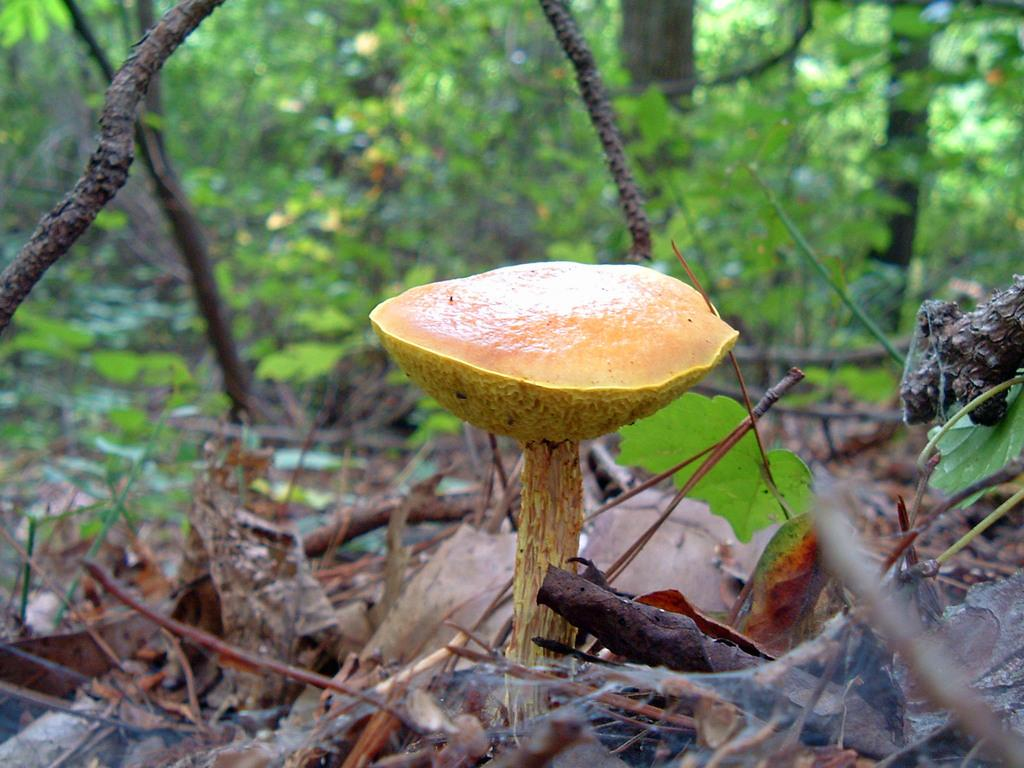What is the main subject of the image? There is a mushroom in the image. What can be seen in the foreground of the image? There are dry leaves in the front of the image. What type of vegetation is visible in the background of the image? There are trees at the back of the image. What color is the hook used by the chess player in the image? There is no chess player or hook present in the image. 